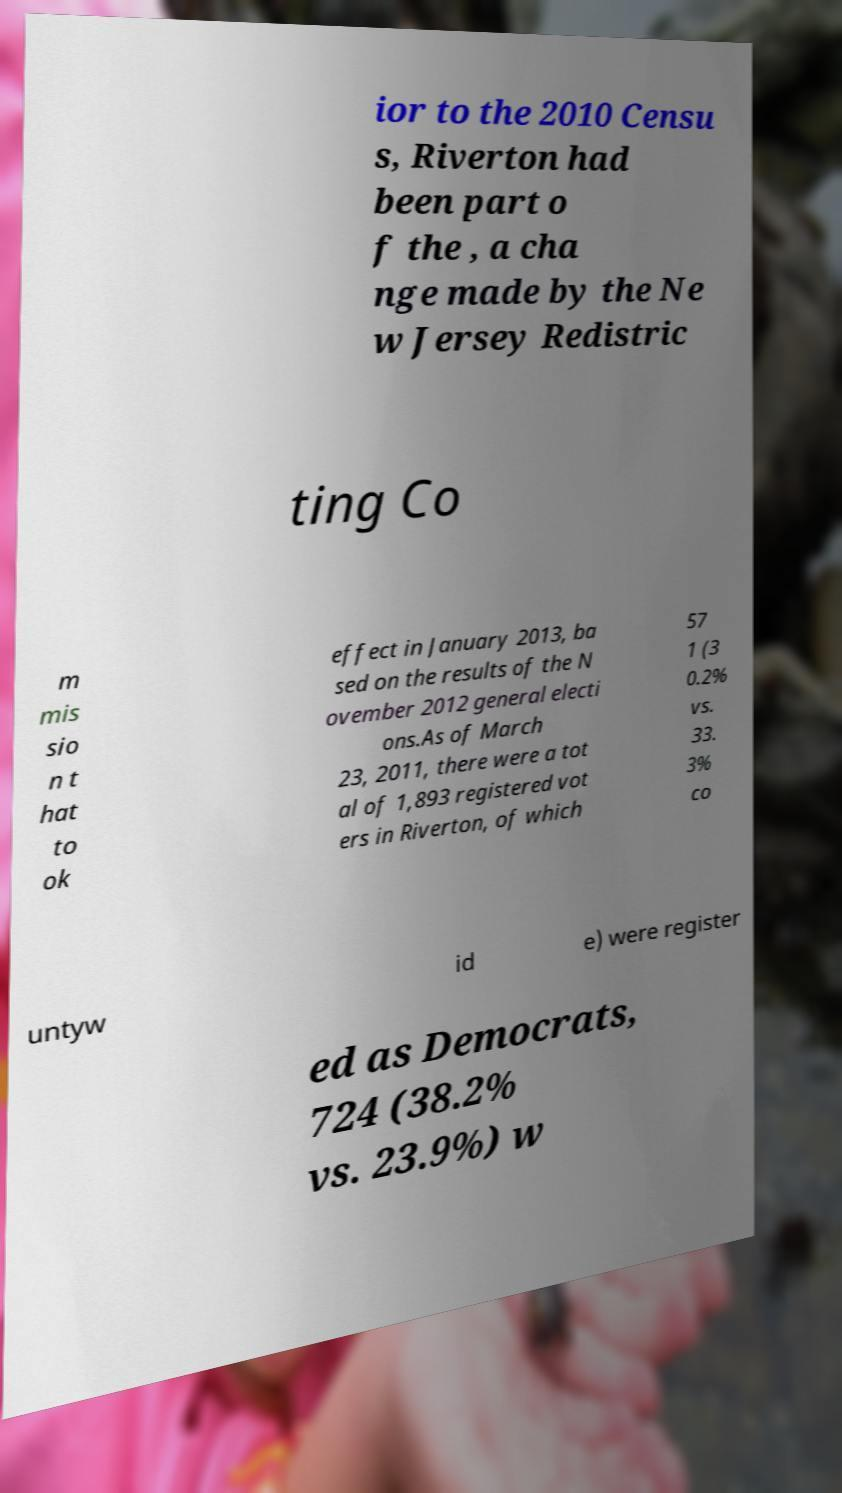Could you extract and type out the text from this image? ior to the 2010 Censu s, Riverton had been part o f the , a cha nge made by the Ne w Jersey Redistric ting Co m mis sio n t hat to ok effect in January 2013, ba sed on the results of the N ovember 2012 general electi ons.As of March 23, 2011, there were a tot al of 1,893 registered vot ers in Riverton, of which 57 1 (3 0.2% vs. 33. 3% co untyw id e) were register ed as Democrats, 724 (38.2% vs. 23.9%) w 